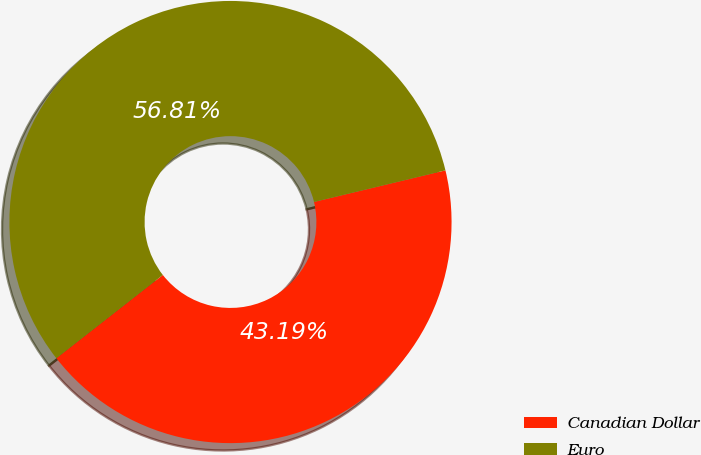Convert chart to OTSL. <chart><loc_0><loc_0><loc_500><loc_500><pie_chart><fcel>Canadian Dollar<fcel>Euro<nl><fcel>43.19%<fcel>56.81%<nl></chart> 